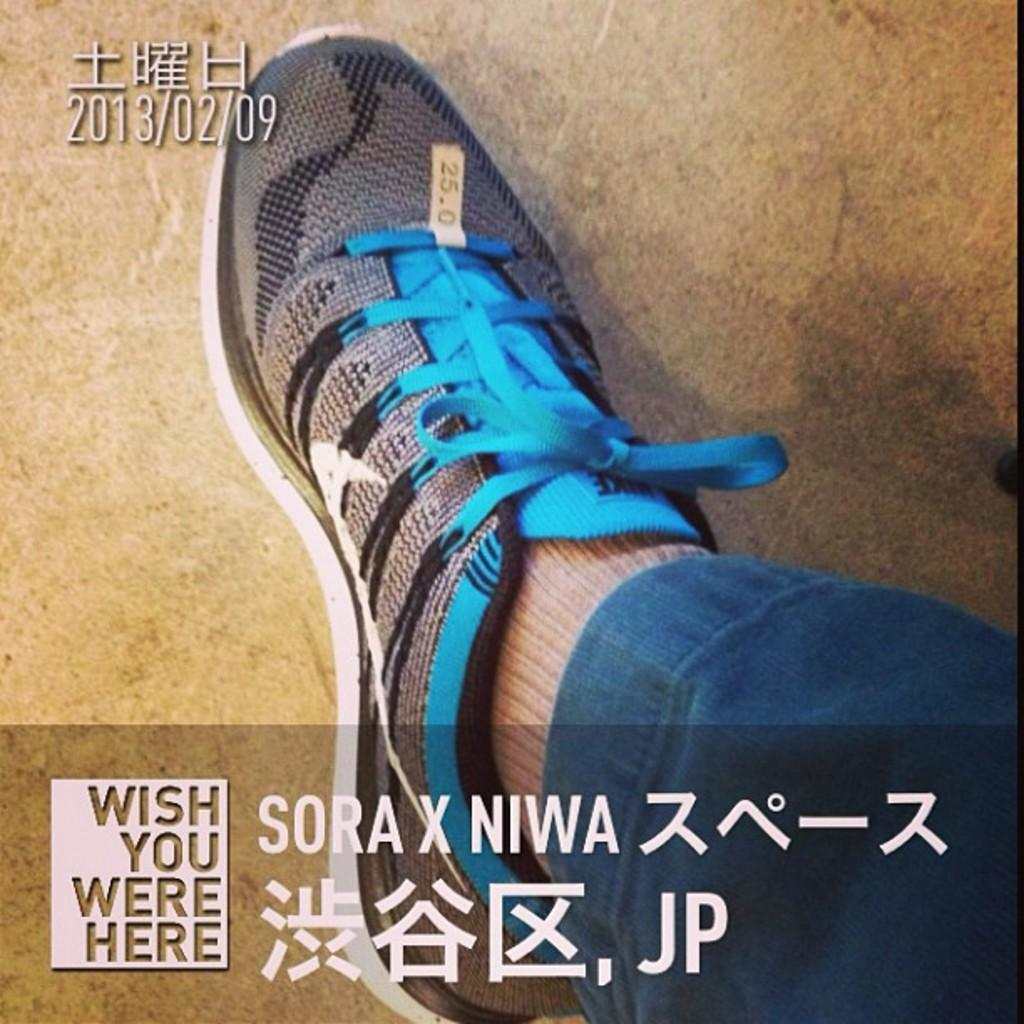What object can be seen in the image that is related to footwear? There is a person's shoe in the image. Can you describe any other features of the image? Yes, there are watermarks present in the image. How many fairies are holding rings in the image? There are no fairies or rings present in the image. What type of drug can be seen in the image? There is no drug present in the image. 